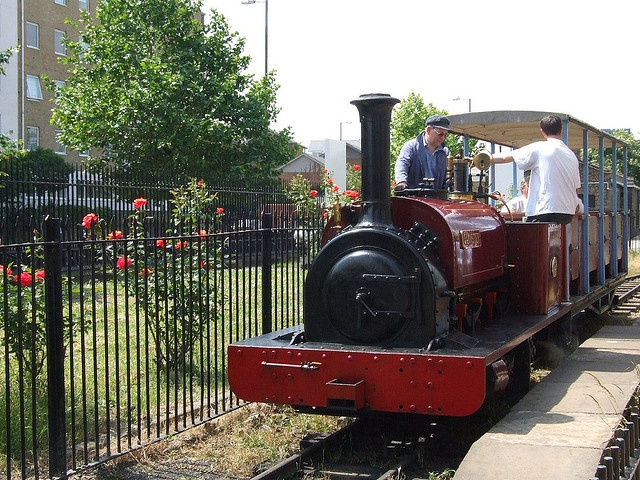Describe the objects in this image and their specific colors. I can see train in lightgray, black, maroon, and gray tones, people in lightgray, lavender, darkgray, and black tones, people in lightgray, gray, navy, lavender, and black tones, and people in lightgray, white, darkgray, pink, and gray tones in this image. 